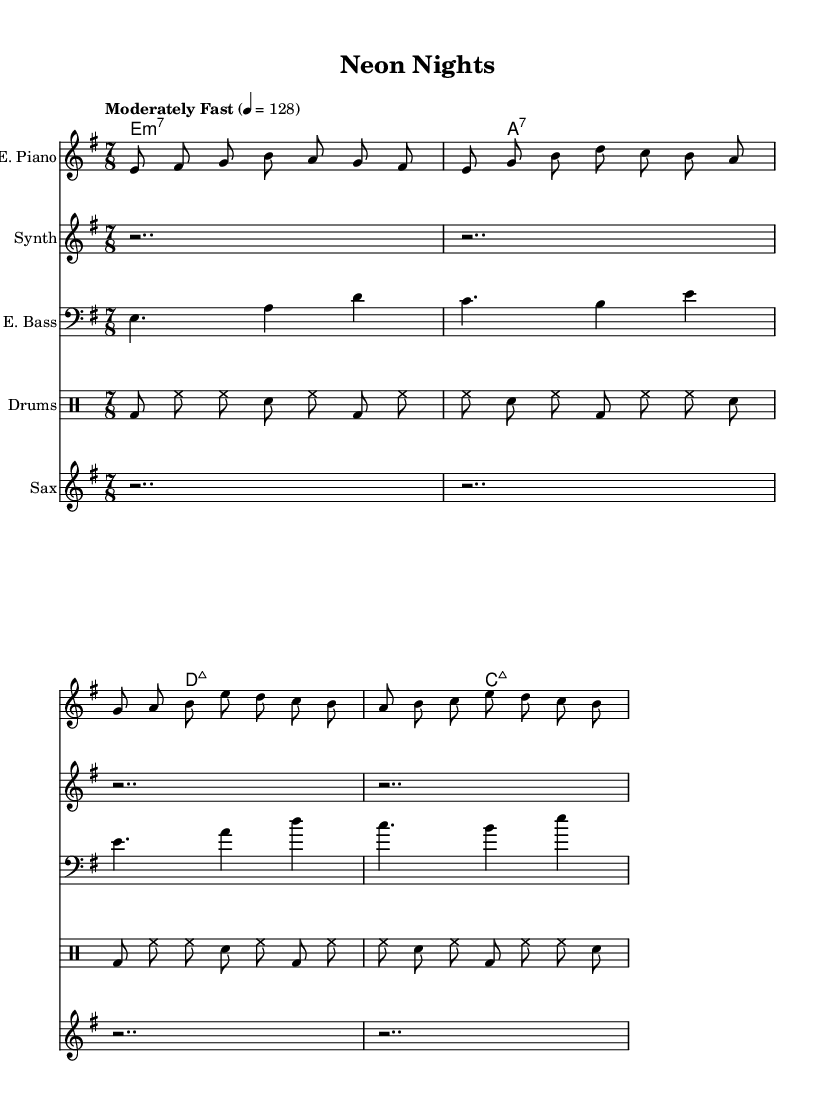What is the key signature of this music? The key signature is E minor, which has one sharp, F#. This is identified by looking at the key signature at the beginning of the staff.
Answer: E minor What is the time signature of this piece? The time signature is 7/8, indicated at the beginning of the score. This means there are seven eighth notes in each measure.
Answer: 7/8 What tempo is indicated for this piece? The tempo is marked as "Moderately Fast" with a metronome marking of 128 beats per minute, written above the staff. This indicates how fast the piece should be played.
Answer: 128 How many measures does the electric piano part contain in the excerpt? By counting the number of distinct groupings of notes between the bar lines in the electric piano part, we identify a total of four measures. Each measure is separated by a vertical line (bar line).
Answer: 4 What chords are used throughout this piece? The chords used are E minor 7, A 7, D major 7, and C major 7, which are indicated in chord names above the staves.
Answer: E minor 7, A 7, D major 7, C major 7 Which instrument has the longest silence in its part? The synthesizer has the longest silence, indicated by the rest symbols shown in its staff that last for two beats. The synthesizer part contains a complete silence (rests) primarily.
Answer: Synthesizer What type of jazz style does this piece represent? This piece represents fusion jazz, blending traditional jazz elements with electronic sounds, indicated by the use of synthesizers and the rhythmic complexity typical of fusion jazz.
Answer: Fusion jazz 